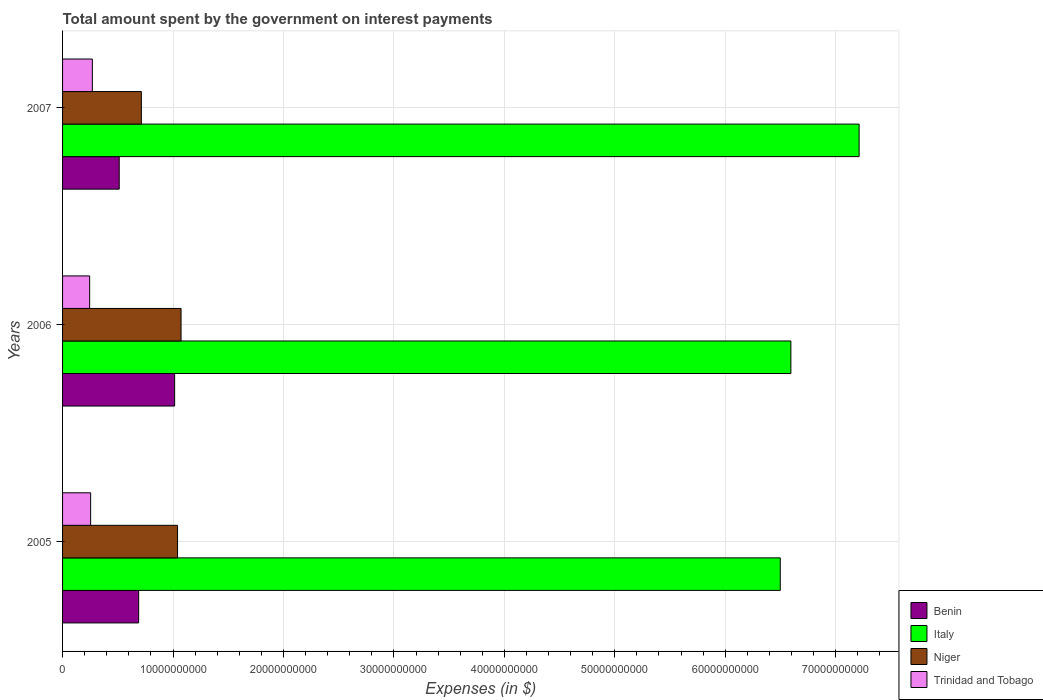How many groups of bars are there?
Your answer should be very brief. 3. Are the number of bars per tick equal to the number of legend labels?
Provide a short and direct response. Yes. How many bars are there on the 3rd tick from the bottom?
Your response must be concise. 4. What is the label of the 3rd group of bars from the top?
Ensure brevity in your answer.  2005. What is the amount spent on interest payments by the government in Benin in 2006?
Keep it short and to the point. 1.01e+1. Across all years, what is the maximum amount spent on interest payments by the government in Benin?
Keep it short and to the point. 1.01e+1. Across all years, what is the minimum amount spent on interest payments by the government in Benin?
Offer a terse response. 5.13e+09. In which year was the amount spent on interest payments by the government in Benin maximum?
Your response must be concise. 2006. What is the total amount spent on interest payments by the government in Trinidad and Tobago in the graph?
Offer a terse response. 7.69e+09. What is the difference between the amount spent on interest payments by the government in Benin in 2005 and that in 2006?
Provide a succinct answer. -3.26e+09. What is the difference between the amount spent on interest payments by the government in Trinidad and Tobago in 2005 and the amount spent on interest payments by the government in Italy in 2007?
Offer a very short reply. -6.96e+1. What is the average amount spent on interest payments by the government in Trinidad and Tobago per year?
Offer a very short reply. 2.56e+09. In the year 2006, what is the difference between the amount spent on interest payments by the government in Benin and amount spent on interest payments by the government in Italy?
Make the answer very short. -5.58e+1. What is the ratio of the amount spent on interest payments by the government in Trinidad and Tobago in 2006 to that in 2007?
Your answer should be compact. 0.91. What is the difference between the highest and the second highest amount spent on interest payments by the government in Niger?
Provide a succinct answer. 3.18e+08. What is the difference between the highest and the lowest amount spent on interest payments by the government in Niger?
Your answer should be compact. 3.59e+09. Is it the case that in every year, the sum of the amount spent on interest payments by the government in Trinidad and Tobago and amount spent on interest payments by the government in Niger is greater than the amount spent on interest payments by the government in Italy?
Your response must be concise. No. How many bars are there?
Make the answer very short. 12. Are the values on the major ticks of X-axis written in scientific E-notation?
Ensure brevity in your answer.  No. Where does the legend appear in the graph?
Your answer should be very brief. Bottom right. How many legend labels are there?
Provide a succinct answer. 4. How are the legend labels stacked?
Make the answer very short. Vertical. What is the title of the graph?
Offer a very short reply. Total amount spent by the government on interest payments. What is the label or title of the X-axis?
Keep it short and to the point. Expenses (in $). What is the label or title of the Y-axis?
Ensure brevity in your answer.  Years. What is the Expenses (in $) in Benin in 2005?
Ensure brevity in your answer.  6.89e+09. What is the Expenses (in $) in Italy in 2005?
Provide a succinct answer. 6.50e+1. What is the Expenses (in $) in Niger in 2005?
Provide a succinct answer. 1.04e+1. What is the Expenses (in $) of Trinidad and Tobago in 2005?
Ensure brevity in your answer.  2.54e+09. What is the Expenses (in $) in Benin in 2006?
Your answer should be very brief. 1.01e+1. What is the Expenses (in $) of Italy in 2006?
Offer a very short reply. 6.59e+1. What is the Expenses (in $) in Niger in 2006?
Provide a succinct answer. 1.07e+1. What is the Expenses (in $) in Trinidad and Tobago in 2006?
Provide a succinct answer. 2.45e+09. What is the Expenses (in $) in Benin in 2007?
Your answer should be compact. 5.13e+09. What is the Expenses (in $) in Italy in 2007?
Offer a very short reply. 7.21e+1. What is the Expenses (in $) in Niger in 2007?
Your answer should be very brief. 7.13e+09. What is the Expenses (in $) in Trinidad and Tobago in 2007?
Provide a succinct answer. 2.70e+09. Across all years, what is the maximum Expenses (in $) in Benin?
Keep it short and to the point. 1.01e+1. Across all years, what is the maximum Expenses (in $) in Italy?
Your answer should be very brief. 7.21e+1. Across all years, what is the maximum Expenses (in $) of Niger?
Keep it short and to the point. 1.07e+1. Across all years, what is the maximum Expenses (in $) of Trinidad and Tobago?
Your answer should be very brief. 2.70e+09. Across all years, what is the minimum Expenses (in $) in Benin?
Give a very brief answer. 5.13e+09. Across all years, what is the minimum Expenses (in $) of Italy?
Offer a very short reply. 6.50e+1. Across all years, what is the minimum Expenses (in $) of Niger?
Your answer should be very brief. 7.13e+09. Across all years, what is the minimum Expenses (in $) in Trinidad and Tobago?
Offer a very short reply. 2.45e+09. What is the total Expenses (in $) of Benin in the graph?
Your answer should be compact. 2.22e+1. What is the total Expenses (in $) of Italy in the graph?
Your response must be concise. 2.03e+11. What is the total Expenses (in $) of Niger in the graph?
Provide a succinct answer. 2.83e+1. What is the total Expenses (in $) in Trinidad and Tobago in the graph?
Provide a short and direct response. 7.69e+09. What is the difference between the Expenses (in $) of Benin in 2005 and that in 2006?
Provide a succinct answer. -3.26e+09. What is the difference between the Expenses (in $) in Italy in 2005 and that in 2006?
Your answer should be compact. -9.61e+08. What is the difference between the Expenses (in $) of Niger in 2005 and that in 2006?
Keep it short and to the point. -3.18e+08. What is the difference between the Expenses (in $) of Trinidad and Tobago in 2005 and that in 2006?
Make the answer very short. 8.82e+07. What is the difference between the Expenses (in $) in Benin in 2005 and that in 2007?
Your answer should be very brief. 1.76e+09. What is the difference between the Expenses (in $) of Italy in 2005 and that in 2007?
Make the answer very short. -7.14e+09. What is the difference between the Expenses (in $) in Niger in 2005 and that in 2007?
Give a very brief answer. 3.28e+09. What is the difference between the Expenses (in $) of Trinidad and Tobago in 2005 and that in 2007?
Offer a very short reply. -1.57e+08. What is the difference between the Expenses (in $) in Benin in 2006 and that in 2007?
Keep it short and to the point. 5.02e+09. What is the difference between the Expenses (in $) of Italy in 2006 and that in 2007?
Offer a very short reply. -6.18e+09. What is the difference between the Expenses (in $) in Niger in 2006 and that in 2007?
Provide a short and direct response. 3.59e+09. What is the difference between the Expenses (in $) of Trinidad and Tobago in 2006 and that in 2007?
Give a very brief answer. -2.45e+08. What is the difference between the Expenses (in $) in Benin in 2005 and the Expenses (in $) in Italy in 2006?
Your answer should be very brief. -5.91e+1. What is the difference between the Expenses (in $) of Benin in 2005 and the Expenses (in $) of Niger in 2006?
Your response must be concise. -3.84e+09. What is the difference between the Expenses (in $) of Benin in 2005 and the Expenses (in $) of Trinidad and Tobago in 2006?
Provide a succinct answer. 4.44e+09. What is the difference between the Expenses (in $) of Italy in 2005 and the Expenses (in $) of Niger in 2006?
Provide a succinct answer. 5.43e+1. What is the difference between the Expenses (in $) in Italy in 2005 and the Expenses (in $) in Trinidad and Tobago in 2006?
Provide a succinct answer. 6.25e+1. What is the difference between the Expenses (in $) of Niger in 2005 and the Expenses (in $) of Trinidad and Tobago in 2006?
Give a very brief answer. 7.96e+09. What is the difference between the Expenses (in $) in Benin in 2005 and the Expenses (in $) in Italy in 2007?
Offer a very short reply. -6.52e+1. What is the difference between the Expenses (in $) of Benin in 2005 and the Expenses (in $) of Niger in 2007?
Offer a terse response. -2.44e+08. What is the difference between the Expenses (in $) of Benin in 2005 and the Expenses (in $) of Trinidad and Tobago in 2007?
Ensure brevity in your answer.  4.19e+09. What is the difference between the Expenses (in $) in Italy in 2005 and the Expenses (in $) in Niger in 2007?
Offer a very short reply. 5.78e+1. What is the difference between the Expenses (in $) in Italy in 2005 and the Expenses (in $) in Trinidad and Tobago in 2007?
Your response must be concise. 6.23e+1. What is the difference between the Expenses (in $) of Niger in 2005 and the Expenses (in $) of Trinidad and Tobago in 2007?
Ensure brevity in your answer.  7.71e+09. What is the difference between the Expenses (in $) of Benin in 2006 and the Expenses (in $) of Italy in 2007?
Offer a terse response. -6.20e+1. What is the difference between the Expenses (in $) in Benin in 2006 and the Expenses (in $) in Niger in 2007?
Provide a succinct answer. 3.01e+09. What is the difference between the Expenses (in $) in Benin in 2006 and the Expenses (in $) in Trinidad and Tobago in 2007?
Keep it short and to the point. 7.45e+09. What is the difference between the Expenses (in $) of Italy in 2006 and the Expenses (in $) of Niger in 2007?
Make the answer very short. 5.88e+1. What is the difference between the Expenses (in $) of Italy in 2006 and the Expenses (in $) of Trinidad and Tobago in 2007?
Provide a short and direct response. 6.32e+1. What is the difference between the Expenses (in $) in Niger in 2006 and the Expenses (in $) in Trinidad and Tobago in 2007?
Ensure brevity in your answer.  8.03e+09. What is the average Expenses (in $) in Benin per year?
Keep it short and to the point. 7.39e+09. What is the average Expenses (in $) in Italy per year?
Ensure brevity in your answer.  6.77e+1. What is the average Expenses (in $) of Niger per year?
Your answer should be very brief. 9.42e+09. What is the average Expenses (in $) in Trinidad and Tobago per year?
Provide a short and direct response. 2.56e+09. In the year 2005, what is the difference between the Expenses (in $) in Benin and Expenses (in $) in Italy?
Provide a short and direct response. -5.81e+1. In the year 2005, what is the difference between the Expenses (in $) of Benin and Expenses (in $) of Niger?
Give a very brief answer. -3.52e+09. In the year 2005, what is the difference between the Expenses (in $) of Benin and Expenses (in $) of Trinidad and Tobago?
Make the answer very short. 4.35e+09. In the year 2005, what is the difference between the Expenses (in $) in Italy and Expenses (in $) in Niger?
Keep it short and to the point. 5.46e+1. In the year 2005, what is the difference between the Expenses (in $) in Italy and Expenses (in $) in Trinidad and Tobago?
Give a very brief answer. 6.24e+1. In the year 2005, what is the difference between the Expenses (in $) of Niger and Expenses (in $) of Trinidad and Tobago?
Offer a very short reply. 7.87e+09. In the year 2006, what is the difference between the Expenses (in $) in Benin and Expenses (in $) in Italy?
Provide a succinct answer. -5.58e+1. In the year 2006, what is the difference between the Expenses (in $) of Benin and Expenses (in $) of Niger?
Make the answer very short. -5.80e+08. In the year 2006, what is the difference between the Expenses (in $) in Benin and Expenses (in $) in Trinidad and Tobago?
Keep it short and to the point. 7.69e+09. In the year 2006, what is the difference between the Expenses (in $) of Italy and Expenses (in $) of Niger?
Your response must be concise. 5.52e+1. In the year 2006, what is the difference between the Expenses (in $) of Italy and Expenses (in $) of Trinidad and Tobago?
Offer a very short reply. 6.35e+1. In the year 2006, what is the difference between the Expenses (in $) of Niger and Expenses (in $) of Trinidad and Tobago?
Your response must be concise. 8.27e+09. In the year 2007, what is the difference between the Expenses (in $) of Benin and Expenses (in $) of Italy?
Offer a terse response. -6.70e+1. In the year 2007, what is the difference between the Expenses (in $) in Benin and Expenses (in $) in Niger?
Provide a succinct answer. -2.01e+09. In the year 2007, what is the difference between the Expenses (in $) in Benin and Expenses (in $) in Trinidad and Tobago?
Make the answer very short. 2.43e+09. In the year 2007, what is the difference between the Expenses (in $) in Italy and Expenses (in $) in Niger?
Offer a very short reply. 6.50e+1. In the year 2007, what is the difference between the Expenses (in $) of Italy and Expenses (in $) of Trinidad and Tobago?
Offer a terse response. 6.94e+1. In the year 2007, what is the difference between the Expenses (in $) in Niger and Expenses (in $) in Trinidad and Tobago?
Your response must be concise. 4.44e+09. What is the ratio of the Expenses (in $) of Benin in 2005 to that in 2006?
Your response must be concise. 0.68. What is the ratio of the Expenses (in $) in Italy in 2005 to that in 2006?
Keep it short and to the point. 0.99. What is the ratio of the Expenses (in $) of Niger in 2005 to that in 2006?
Offer a very short reply. 0.97. What is the ratio of the Expenses (in $) in Trinidad and Tobago in 2005 to that in 2006?
Keep it short and to the point. 1.04. What is the ratio of the Expenses (in $) of Benin in 2005 to that in 2007?
Your response must be concise. 1.34. What is the ratio of the Expenses (in $) in Italy in 2005 to that in 2007?
Give a very brief answer. 0.9. What is the ratio of the Expenses (in $) of Niger in 2005 to that in 2007?
Make the answer very short. 1.46. What is the ratio of the Expenses (in $) in Trinidad and Tobago in 2005 to that in 2007?
Give a very brief answer. 0.94. What is the ratio of the Expenses (in $) in Benin in 2006 to that in 2007?
Your answer should be very brief. 1.98. What is the ratio of the Expenses (in $) of Italy in 2006 to that in 2007?
Offer a terse response. 0.91. What is the ratio of the Expenses (in $) in Niger in 2006 to that in 2007?
Make the answer very short. 1.5. What is the ratio of the Expenses (in $) in Trinidad and Tobago in 2006 to that in 2007?
Your answer should be compact. 0.91. What is the difference between the highest and the second highest Expenses (in $) in Benin?
Ensure brevity in your answer.  3.26e+09. What is the difference between the highest and the second highest Expenses (in $) in Italy?
Provide a short and direct response. 6.18e+09. What is the difference between the highest and the second highest Expenses (in $) in Niger?
Provide a succinct answer. 3.18e+08. What is the difference between the highest and the second highest Expenses (in $) of Trinidad and Tobago?
Ensure brevity in your answer.  1.57e+08. What is the difference between the highest and the lowest Expenses (in $) of Benin?
Offer a terse response. 5.02e+09. What is the difference between the highest and the lowest Expenses (in $) in Italy?
Your answer should be very brief. 7.14e+09. What is the difference between the highest and the lowest Expenses (in $) of Niger?
Offer a very short reply. 3.59e+09. What is the difference between the highest and the lowest Expenses (in $) in Trinidad and Tobago?
Offer a very short reply. 2.45e+08. 